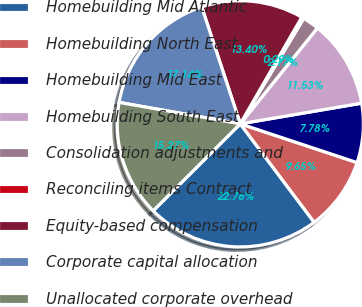<chart> <loc_0><loc_0><loc_500><loc_500><pie_chart><fcel>Homebuilding Mid Atlantic<fcel>Homebuilding North East<fcel>Homebuilding Mid East<fcel>Homebuilding South East<fcel>Consolidation adjustments and<fcel>Reconciling items Contract<fcel>Equity-based compensation<fcel>Corporate capital allocation<fcel>Unallocated corporate overhead<nl><fcel>22.76%<fcel>9.65%<fcel>7.78%<fcel>11.53%<fcel>2.17%<fcel>0.29%<fcel>13.4%<fcel>17.14%<fcel>15.27%<nl></chart> 